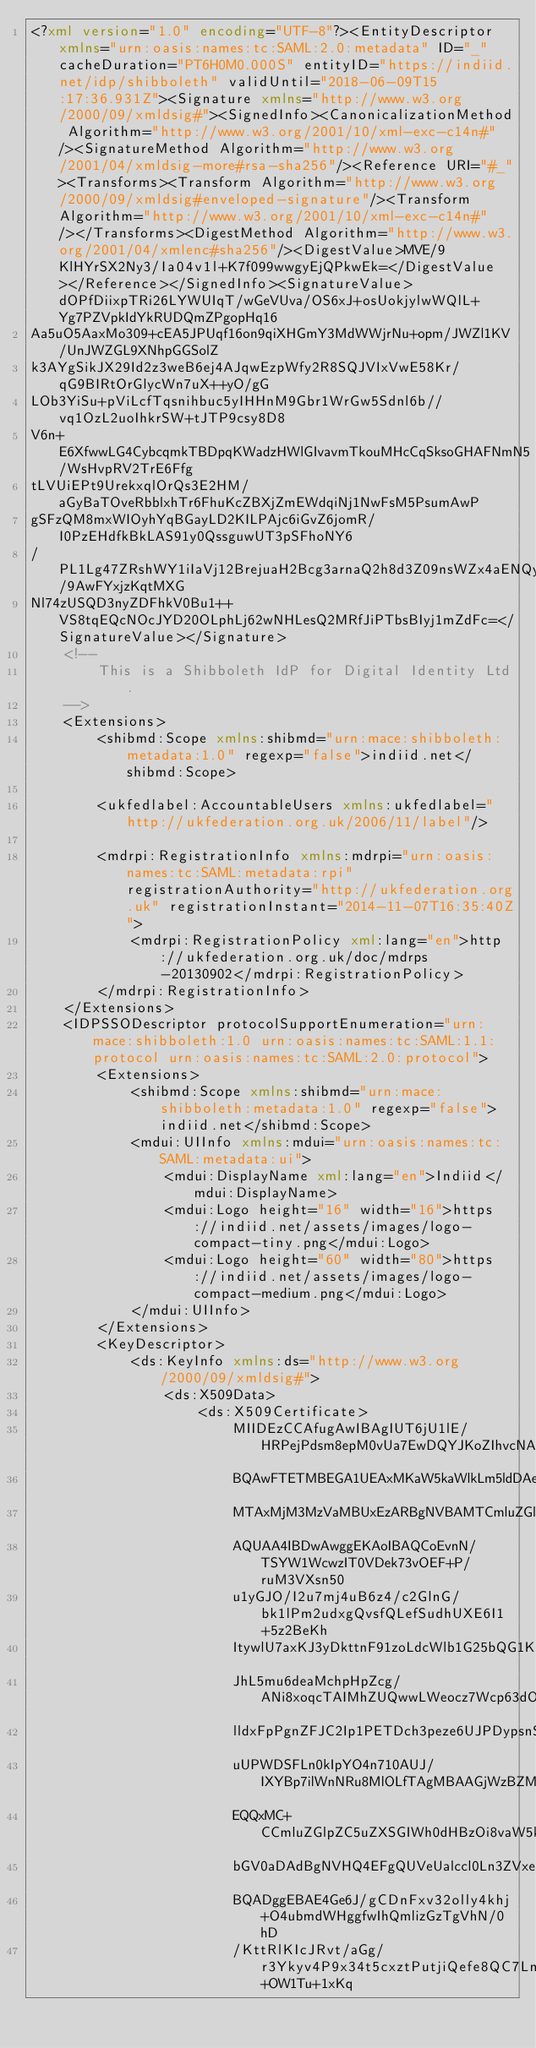Convert code to text. <code><loc_0><loc_0><loc_500><loc_500><_XML_><?xml version="1.0" encoding="UTF-8"?><EntityDescriptor xmlns="urn:oasis:names:tc:SAML:2.0:metadata" ID="_" cacheDuration="PT6H0M0.000S" entityID="https://indiid.net/idp/shibboleth" validUntil="2018-06-09T15:17:36.931Z"><Signature xmlns="http://www.w3.org/2000/09/xmldsig#"><SignedInfo><CanonicalizationMethod Algorithm="http://www.w3.org/2001/10/xml-exc-c14n#"/><SignatureMethod Algorithm="http://www.w3.org/2001/04/xmldsig-more#rsa-sha256"/><Reference URI="#_"><Transforms><Transform Algorithm="http://www.w3.org/2000/09/xmldsig#enveloped-signature"/><Transform Algorithm="http://www.w3.org/2001/10/xml-exc-c14n#"/></Transforms><DigestMethod Algorithm="http://www.w3.org/2001/04/xmlenc#sha256"/><DigestValue>MVE/9KlHYrSX2Ny3/Ia04v1l+K7f099wwgyEjQPkwEk=</DigestValue></Reference></SignedInfo><SignatureValue>dOPfDiixpTRi26LYWUIqT/wGeVUva/OS6xJ+osUokjylwWQlL+Yg7PZVpkIdYkRUDQmZPgopHq16
Aa5uO5AaxMo309+cEA5JPUqf16on9qiXHGmY3MdWWjrNu+opm/JWZl1KV/UnJWZGL9XNhpGGSolZ
k3AYgSikJX29Id2z3weB6ej4AJqwEzpWfy2R8SQJVIxVwE58Kr/qG9BIRtOrGlycWn7uX++yO/gG
LOb3YiSu+pViLcfTqsnihbuc5yIHHnM9Gbr1WrGw5Sdnl6b//vq1OzL2uoIhkrSW+tJTP9csy8D8
V6n+E6XfwwLG4CybcqmkTBDpqKWadzHWlGIvavmTkouMHcCqSksoGHAFNmN5/WsHvpRV2TrE6Ffg
tLVUiEPt9UrekxqlOrQs3E2HM/aGyBaTOveRbblxhTr6FhuKcZBXjZmEWdqiNj1NwFsM5PsumAwP
gSFzQM8mxWIOyhYqBGayLD2KILPAjc6iGvZ6jomR/I0PzEHdfkBkLAS91y0QssguwUT3pSFhoNY6
/PL1Lg47ZRshWY1iIaVj12BrejuaH2Bcg3arnaQ2h8d3Z09nsWZx4aENQy20x/9AwFYxjzKqtMXG
Nl74zUSQD3nyZDFhkV0Bu1++VS8tqEQcNOcJYD20OLphLj62wNHLesQ2MRfJiPTbsBIyj1mZdFc=</SignatureValue></Signature>
	<!--
		This is a Shibboleth IdP for Digital Identity Ltd.
	-->
	<Extensions>
		<shibmd:Scope xmlns:shibmd="urn:mace:shibboleth:metadata:1.0" regexp="false">indiid.net</shibmd:Scope>
		
		<ukfedlabel:AccountableUsers xmlns:ukfedlabel="http://ukfederation.org.uk/2006/11/label"/>

		<mdrpi:RegistrationInfo xmlns:mdrpi="urn:oasis:names:tc:SAML:metadata:rpi" registrationAuthority="http://ukfederation.org.uk" registrationInstant="2014-11-07T16:35:40Z">
			<mdrpi:RegistrationPolicy xml:lang="en">http://ukfederation.org.uk/doc/mdrps-20130902</mdrpi:RegistrationPolicy>
		</mdrpi:RegistrationInfo>
	</Extensions>
	<IDPSSODescriptor protocolSupportEnumeration="urn:mace:shibboleth:1.0 urn:oasis:names:tc:SAML:1.1:protocol urn:oasis:names:tc:SAML:2.0:protocol">
		<Extensions>
			<shibmd:Scope xmlns:shibmd="urn:mace:shibboleth:metadata:1.0" regexp="false">indiid.net</shibmd:Scope>
			<mdui:UIInfo xmlns:mdui="urn:oasis:names:tc:SAML:metadata:ui">
				<mdui:DisplayName xml:lang="en">Indiid</mdui:DisplayName>
				<mdui:Logo height="16" width="16">https://indiid.net/assets/images/logo-compact-tiny.png</mdui:Logo>
				<mdui:Logo height="60" width="80">https://indiid.net/assets/images/logo-compact-medium.png</mdui:Logo>
			</mdui:UIInfo>
		</Extensions>
		<KeyDescriptor>
			<ds:KeyInfo xmlns:ds="http://www.w3.org/2000/09/xmldsig#">
				<ds:X509Data>
					<ds:X509Certificate>
						MIIDEzCCAfugAwIBAgIUT6jU1lE/HRPejPdsm8epM0vUa7EwDQYJKoZIhvcNAQEF
						BQAwFTETMBEGA1UEAxMKaW5kaWlkLm5ldDAeFw0xNDExMTAxMjM3MzVaFw0zNDEx
						MTAxMjM3MzVaMBUxEzARBgNVBAMTCmluZGlpZC5uZXQwggEiMA0GCSqGSIb3DQEB
						AQUAA4IBDwAwggEKAoIBAQCoEvnN/TSYW1WcwzIT0VDek73vOEF+P/ruM3VXsn50
						u1yGJO/I2u7mj4uB6z4/c2GlnG/bk1lPm2udxgQvsfQLefSudhUXE6I1+5z2BeKh
						ItywlU7axKJ3yDkttnF91zoLdcWlb1G25bQG1KCeU5MOEJIwEi6AgNemEWcGyUDN
						JhL5mu6deaMchpHpZcg/ANi8xoqcTAIMhZUQwwLWeocz7Wcp63dO6fXy0lY05udD
						lldxFpPgnZFJC2Ip1PETDch3peze6UJPDypsnSMuq4d05OU8Ys2bXe5nnTxUFUMf
						uUPWDSFLn0kIpYO4n710AUJ/IXYBp7ilWnNRu8MlOLfTAgMBAAGjWzBZMDgGA1Ud
						EQQxMC+CCmluZGlpZC5uZXSGIWh0dHBzOi8vaW5kaWlkLm5ldC9pZHAvc2hpYmJv
						bGV0aDAdBgNVHQ4EFgQUVeUalccl0Ln3ZVxeQvuTCxr5v8swDQYJKoZIhvcNAQEF
						BQADggEBAE4Ge6J/gCDnFxv32olly4khj+O4ubmdWHggfwIhQmlizGzTgVhN/0hD
						/KttRlKIcJRvt/aGg/r3Ykyv4P9x34t5cxztPutjiQefe8QC7Lnxo+OW1Tu+1xKq</code> 